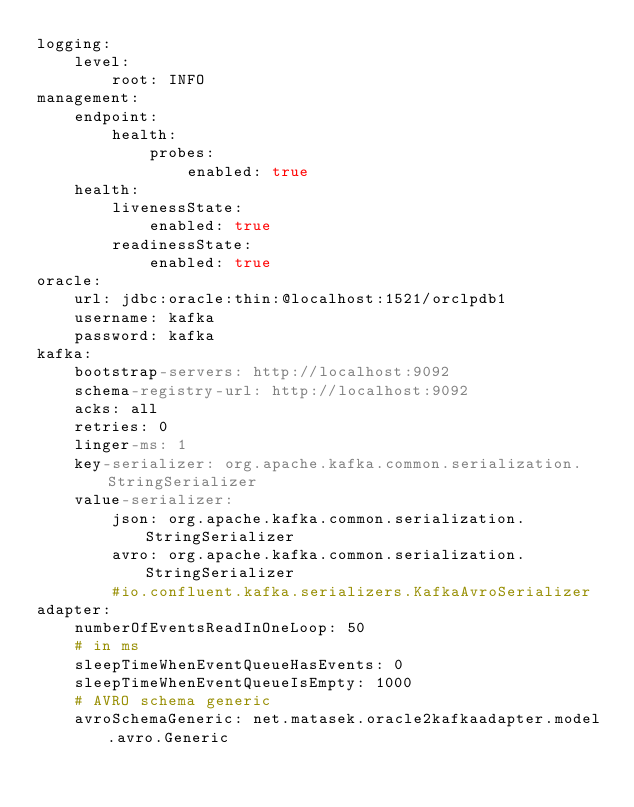<code> <loc_0><loc_0><loc_500><loc_500><_YAML_>logging:
    level:
        root: INFO
management:
    endpoint:
        health:
            probes:
                enabled: true
    health:
        livenessState:
            enabled: true
        readinessState:
            enabled: true
oracle:
    url: jdbc:oracle:thin:@localhost:1521/orclpdb1
    username: kafka
    password: kafka
kafka:
    bootstrap-servers: http://localhost:9092
    schema-registry-url: http://localhost:9092
    acks: all
    retries: 0
    linger-ms: 1
    key-serializer: org.apache.kafka.common.serialization.StringSerializer
    value-serializer:
        json: org.apache.kafka.common.serialization.StringSerializer
        avro: org.apache.kafka.common.serialization.StringSerializer
        #io.confluent.kafka.serializers.KafkaAvroSerializer
adapter:
    numberOfEventsReadInOneLoop: 50
    # in ms
    sleepTimeWhenEventQueueHasEvents: 0
    sleepTimeWhenEventQueueIsEmpty: 1000
    # AVRO schema generic
    avroSchemaGeneric: net.matasek.oracle2kafkaadapter.model.avro.Generic
</code> 